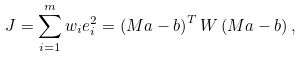Convert formula to latex. <formula><loc_0><loc_0><loc_500><loc_500>J = \sum _ { i = 1 } ^ { m } w _ { i } e _ { i } ^ { 2 } = \left ( M a - b \right ) ^ { T } W \left ( M a - b \right ) ,</formula> 